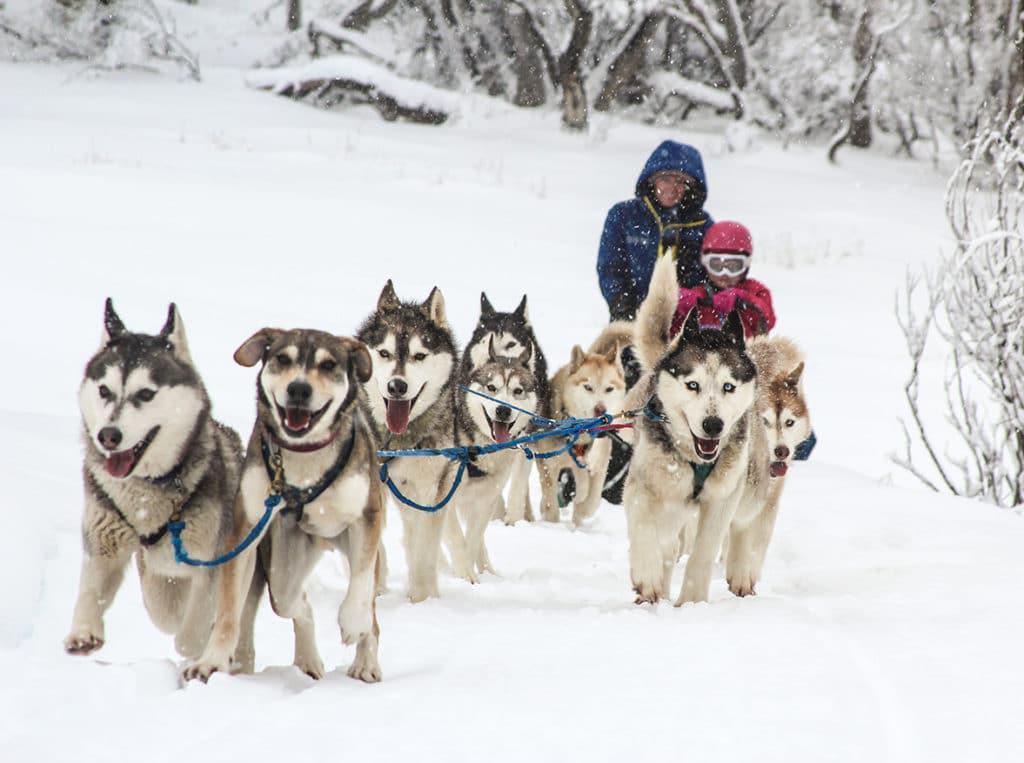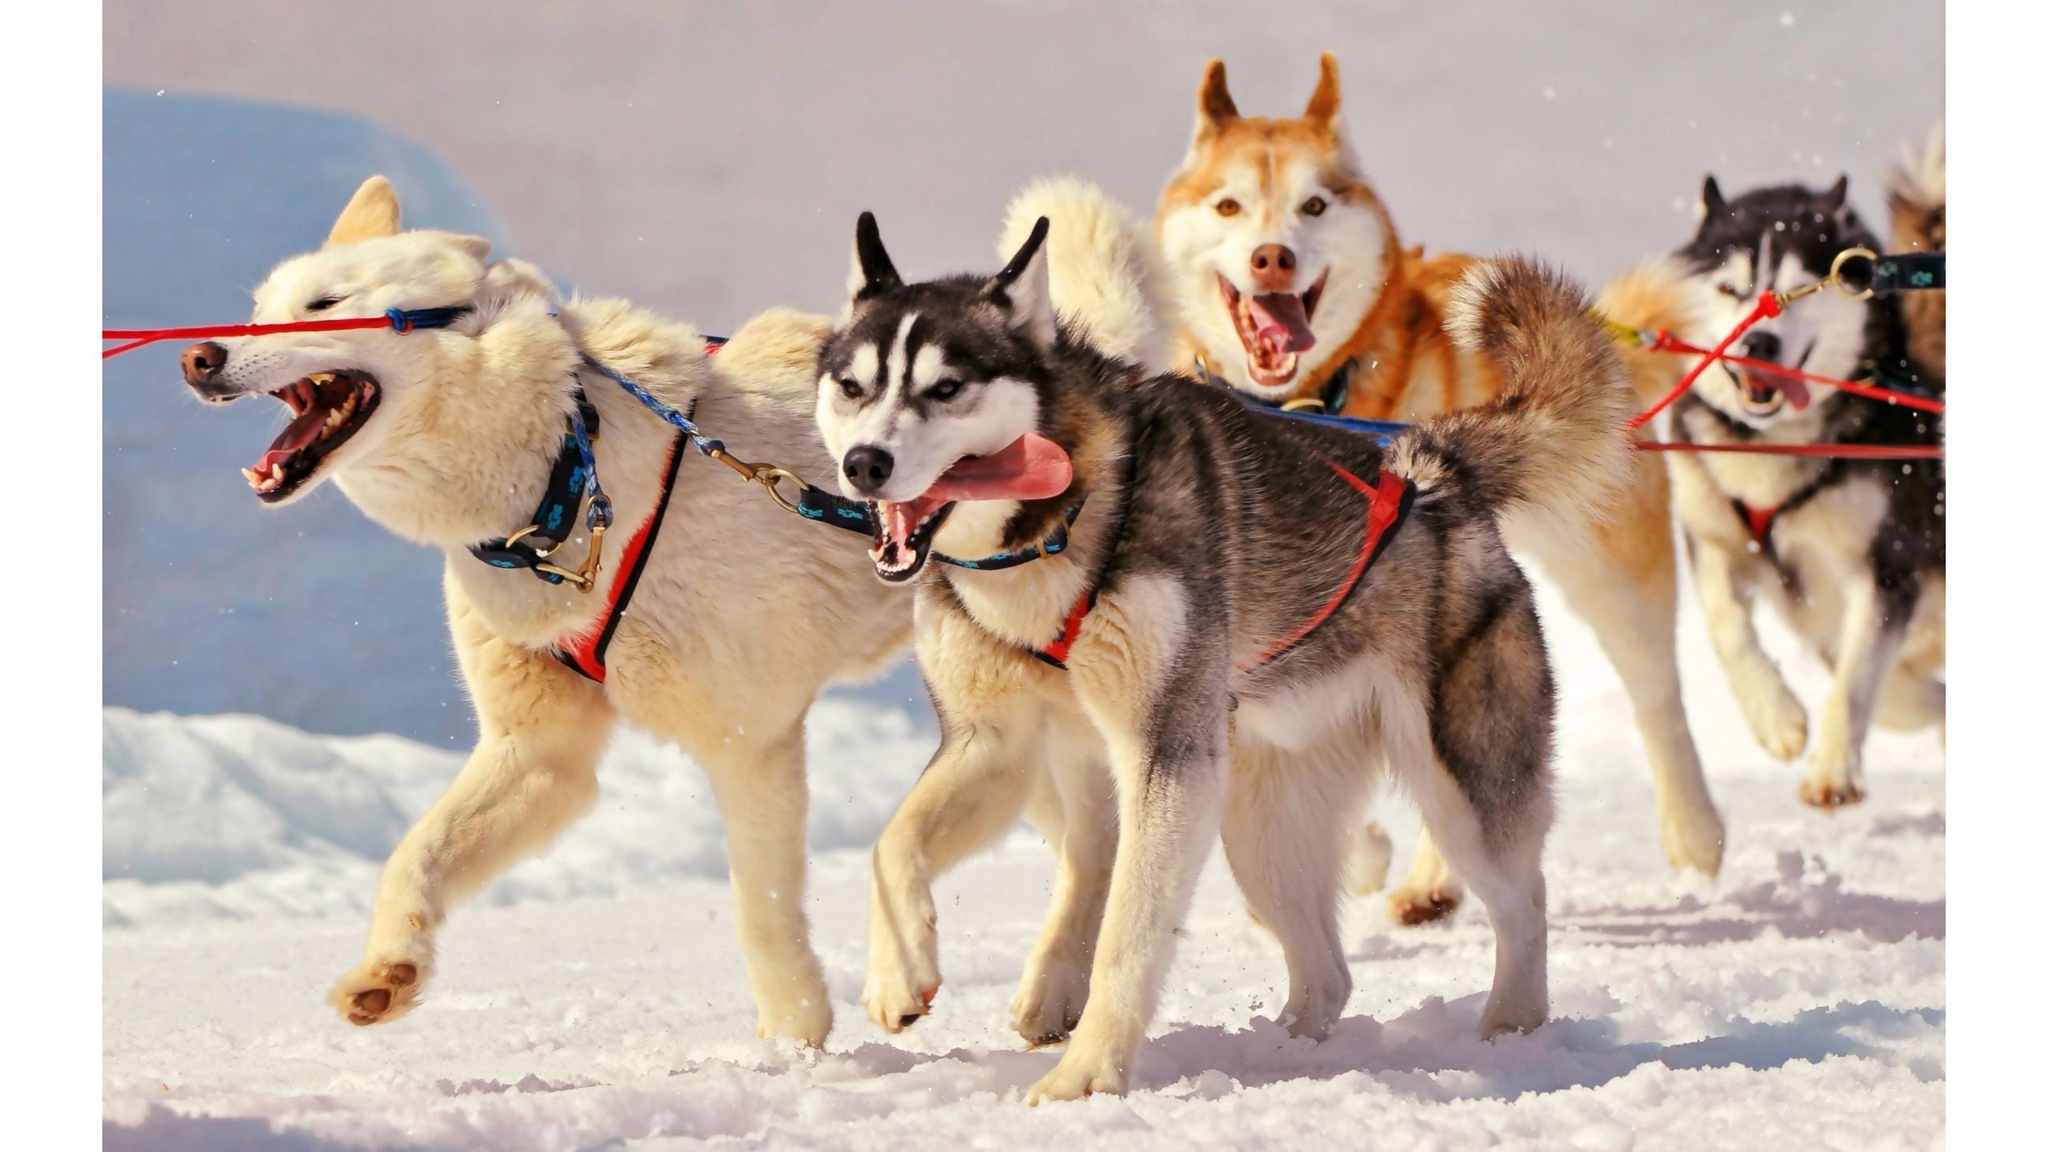The first image is the image on the left, the second image is the image on the right. Considering the images on both sides, is "No lead sled dogs wear booties, and a sled driver is not visible in at least one image." valid? Answer yes or no. Yes. The first image is the image on the left, the second image is the image on the right. For the images shown, is this caption "One image shows a dog sled team without a person." true? Answer yes or no. Yes. 